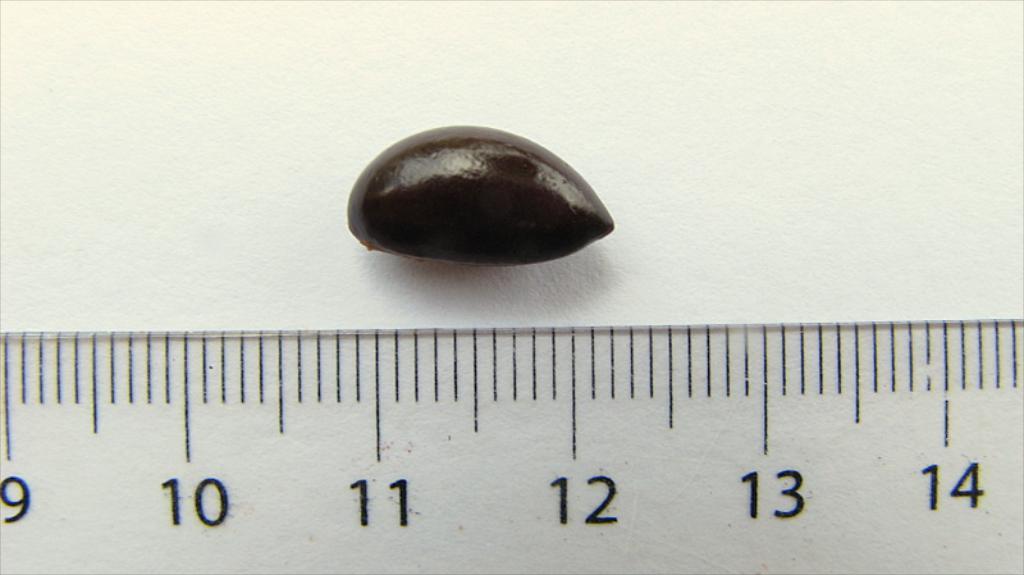Could you give a brief overview of what you see in this image? This image consists of numbers, lines and some object on a wall. This image taken, maybe in a hall. 